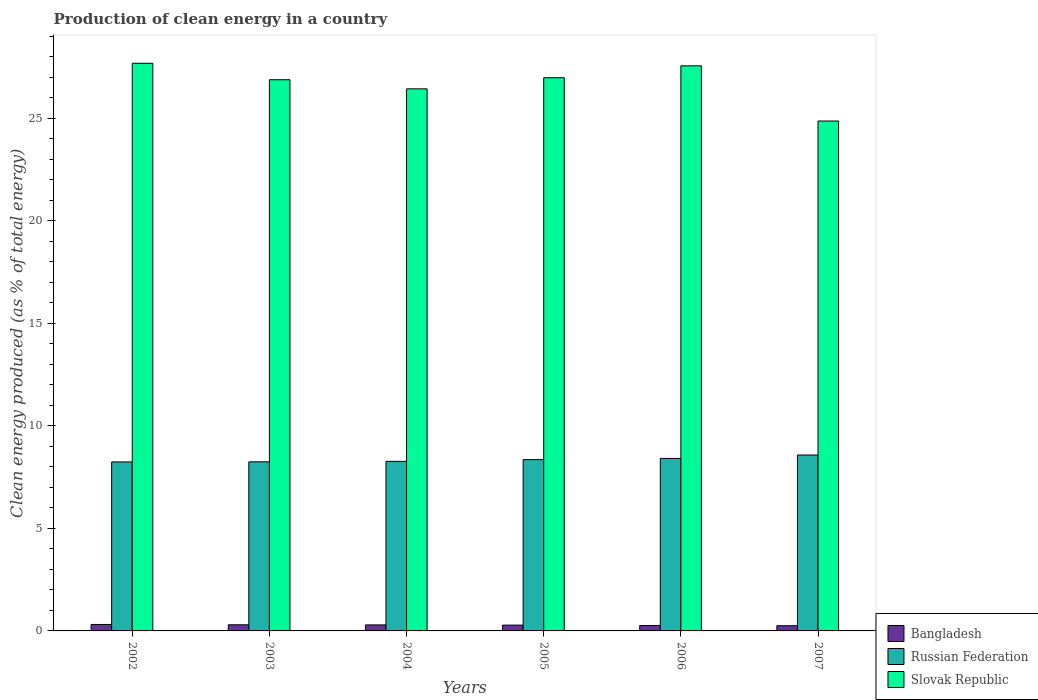Are the number of bars per tick equal to the number of legend labels?
Offer a terse response. Yes. How many bars are there on the 6th tick from the left?
Ensure brevity in your answer.  3. How many bars are there on the 1st tick from the right?
Provide a short and direct response. 3. What is the percentage of clean energy produced in Slovak Republic in 2007?
Offer a terse response. 24.87. Across all years, what is the maximum percentage of clean energy produced in Slovak Republic?
Ensure brevity in your answer.  27.69. Across all years, what is the minimum percentage of clean energy produced in Slovak Republic?
Your answer should be very brief. 24.87. In which year was the percentage of clean energy produced in Russian Federation minimum?
Your answer should be very brief. 2002. What is the total percentage of clean energy produced in Bangladesh in the graph?
Offer a very short reply. 1.71. What is the difference between the percentage of clean energy produced in Russian Federation in 2005 and that in 2007?
Give a very brief answer. -0.22. What is the difference between the percentage of clean energy produced in Russian Federation in 2007 and the percentage of clean energy produced in Slovak Republic in 2006?
Keep it short and to the point. -18.98. What is the average percentage of clean energy produced in Bangladesh per year?
Make the answer very short. 0.28. In the year 2002, what is the difference between the percentage of clean energy produced in Russian Federation and percentage of clean energy produced in Bangladesh?
Your response must be concise. 7.93. In how many years, is the percentage of clean energy produced in Russian Federation greater than 8 %?
Your response must be concise. 6. What is the ratio of the percentage of clean energy produced in Russian Federation in 2003 to that in 2004?
Keep it short and to the point. 1. Is the difference between the percentage of clean energy produced in Russian Federation in 2003 and 2006 greater than the difference between the percentage of clean energy produced in Bangladesh in 2003 and 2006?
Make the answer very short. No. What is the difference between the highest and the second highest percentage of clean energy produced in Russian Federation?
Your answer should be compact. 0.17. What is the difference between the highest and the lowest percentage of clean energy produced in Bangladesh?
Offer a terse response. 0.06. Is the sum of the percentage of clean energy produced in Bangladesh in 2004 and 2005 greater than the maximum percentage of clean energy produced in Russian Federation across all years?
Offer a very short reply. No. What does the 3rd bar from the left in 2006 represents?
Provide a succinct answer. Slovak Republic. What does the 2nd bar from the right in 2006 represents?
Offer a terse response. Russian Federation. Is it the case that in every year, the sum of the percentage of clean energy produced in Slovak Republic and percentage of clean energy produced in Bangladesh is greater than the percentage of clean energy produced in Russian Federation?
Ensure brevity in your answer.  Yes. Are all the bars in the graph horizontal?
Provide a short and direct response. No. What is the difference between two consecutive major ticks on the Y-axis?
Ensure brevity in your answer.  5. Are the values on the major ticks of Y-axis written in scientific E-notation?
Ensure brevity in your answer.  No. Does the graph contain any zero values?
Your answer should be compact. No. Does the graph contain grids?
Your answer should be compact. No. Where does the legend appear in the graph?
Give a very brief answer. Bottom right. What is the title of the graph?
Your answer should be very brief. Production of clean energy in a country. Does "Germany" appear as one of the legend labels in the graph?
Offer a very short reply. No. What is the label or title of the Y-axis?
Provide a short and direct response. Clean energy produced (as % of total energy). What is the Clean energy produced (as % of total energy) of Bangladesh in 2002?
Provide a succinct answer. 0.32. What is the Clean energy produced (as % of total energy) of Russian Federation in 2002?
Offer a very short reply. 8.24. What is the Clean energy produced (as % of total energy) in Slovak Republic in 2002?
Ensure brevity in your answer.  27.69. What is the Clean energy produced (as % of total energy) in Bangladesh in 2003?
Provide a short and direct response. 0.3. What is the Clean energy produced (as % of total energy) in Russian Federation in 2003?
Offer a terse response. 8.25. What is the Clean energy produced (as % of total energy) in Slovak Republic in 2003?
Make the answer very short. 26.88. What is the Clean energy produced (as % of total energy) in Bangladesh in 2004?
Keep it short and to the point. 0.29. What is the Clean energy produced (as % of total energy) in Russian Federation in 2004?
Offer a very short reply. 8.27. What is the Clean energy produced (as % of total energy) in Slovak Republic in 2004?
Give a very brief answer. 26.44. What is the Clean energy produced (as % of total energy) of Bangladesh in 2005?
Keep it short and to the point. 0.28. What is the Clean energy produced (as % of total energy) in Russian Federation in 2005?
Offer a terse response. 8.36. What is the Clean energy produced (as % of total energy) in Slovak Republic in 2005?
Offer a terse response. 26.98. What is the Clean energy produced (as % of total energy) of Bangladesh in 2006?
Keep it short and to the point. 0.27. What is the Clean energy produced (as % of total energy) of Russian Federation in 2006?
Make the answer very short. 8.41. What is the Clean energy produced (as % of total energy) in Slovak Republic in 2006?
Give a very brief answer. 27.56. What is the Clean energy produced (as % of total energy) of Bangladesh in 2007?
Provide a succinct answer. 0.25. What is the Clean energy produced (as % of total energy) in Russian Federation in 2007?
Your answer should be compact. 8.58. What is the Clean energy produced (as % of total energy) in Slovak Republic in 2007?
Ensure brevity in your answer.  24.87. Across all years, what is the maximum Clean energy produced (as % of total energy) of Bangladesh?
Make the answer very short. 0.32. Across all years, what is the maximum Clean energy produced (as % of total energy) in Russian Federation?
Your response must be concise. 8.58. Across all years, what is the maximum Clean energy produced (as % of total energy) in Slovak Republic?
Keep it short and to the point. 27.69. Across all years, what is the minimum Clean energy produced (as % of total energy) in Bangladesh?
Your response must be concise. 0.25. Across all years, what is the minimum Clean energy produced (as % of total energy) in Russian Federation?
Your answer should be very brief. 8.24. Across all years, what is the minimum Clean energy produced (as % of total energy) of Slovak Republic?
Make the answer very short. 24.87. What is the total Clean energy produced (as % of total energy) of Bangladesh in the graph?
Offer a terse response. 1.71. What is the total Clean energy produced (as % of total energy) in Russian Federation in the graph?
Offer a terse response. 50.11. What is the total Clean energy produced (as % of total energy) of Slovak Republic in the graph?
Provide a short and direct response. 160.43. What is the difference between the Clean energy produced (as % of total energy) in Bangladesh in 2002 and that in 2003?
Make the answer very short. 0.02. What is the difference between the Clean energy produced (as % of total energy) in Russian Federation in 2002 and that in 2003?
Give a very brief answer. -0. What is the difference between the Clean energy produced (as % of total energy) in Slovak Republic in 2002 and that in 2003?
Provide a short and direct response. 0.8. What is the difference between the Clean energy produced (as % of total energy) of Bangladesh in 2002 and that in 2004?
Your response must be concise. 0.02. What is the difference between the Clean energy produced (as % of total energy) in Russian Federation in 2002 and that in 2004?
Your response must be concise. -0.03. What is the difference between the Clean energy produced (as % of total energy) in Slovak Republic in 2002 and that in 2004?
Give a very brief answer. 1.25. What is the difference between the Clean energy produced (as % of total energy) in Bangladesh in 2002 and that in 2005?
Offer a very short reply. 0.03. What is the difference between the Clean energy produced (as % of total energy) in Russian Federation in 2002 and that in 2005?
Your response must be concise. -0.11. What is the difference between the Clean energy produced (as % of total energy) of Slovak Republic in 2002 and that in 2005?
Give a very brief answer. 0.7. What is the difference between the Clean energy produced (as % of total energy) in Bangladesh in 2002 and that in 2006?
Give a very brief answer. 0.05. What is the difference between the Clean energy produced (as % of total energy) of Russian Federation in 2002 and that in 2006?
Offer a very short reply. -0.17. What is the difference between the Clean energy produced (as % of total energy) of Slovak Republic in 2002 and that in 2006?
Keep it short and to the point. 0.13. What is the difference between the Clean energy produced (as % of total energy) in Bangladesh in 2002 and that in 2007?
Give a very brief answer. 0.06. What is the difference between the Clean energy produced (as % of total energy) of Russian Federation in 2002 and that in 2007?
Offer a terse response. -0.34. What is the difference between the Clean energy produced (as % of total energy) in Slovak Republic in 2002 and that in 2007?
Your answer should be compact. 2.82. What is the difference between the Clean energy produced (as % of total energy) in Bangladesh in 2003 and that in 2004?
Offer a terse response. 0.01. What is the difference between the Clean energy produced (as % of total energy) of Russian Federation in 2003 and that in 2004?
Offer a terse response. -0.02. What is the difference between the Clean energy produced (as % of total energy) in Slovak Republic in 2003 and that in 2004?
Ensure brevity in your answer.  0.44. What is the difference between the Clean energy produced (as % of total energy) of Bangladesh in 2003 and that in 2005?
Ensure brevity in your answer.  0.02. What is the difference between the Clean energy produced (as % of total energy) of Russian Federation in 2003 and that in 2005?
Your answer should be compact. -0.11. What is the difference between the Clean energy produced (as % of total energy) in Slovak Republic in 2003 and that in 2005?
Your answer should be very brief. -0.1. What is the difference between the Clean energy produced (as % of total energy) of Bangladesh in 2003 and that in 2006?
Offer a terse response. 0.03. What is the difference between the Clean energy produced (as % of total energy) in Russian Federation in 2003 and that in 2006?
Your answer should be very brief. -0.17. What is the difference between the Clean energy produced (as % of total energy) in Slovak Republic in 2003 and that in 2006?
Offer a terse response. -0.68. What is the difference between the Clean energy produced (as % of total energy) in Bangladesh in 2003 and that in 2007?
Make the answer very short. 0.05. What is the difference between the Clean energy produced (as % of total energy) in Russian Federation in 2003 and that in 2007?
Offer a very short reply. -0.33. What is the difference between the Clean energy produced (as % of total energy) in Slovak Republic in 2003 and that in 2007?
Your answer should be very brief. 2.01. What is the difference between the Clean energy produced (as % of total energy) in Bangladesh in 2004 and that in 2005?
Keep it short and to the point. 0.01. What is the difference between the Clean energy produced (as % of total energy) in Russian Federation in 2004 and that in 2005?
Provide a succinct answer. -0.09. What is the difference between the Clean energy produced (as % of total energy) in Slovak Republic in 2004 and that in 2005?
Your answer should be compact. -0.54. What is the difference between the Clean energy produced (as % of total energy) in Bangladesh in 2004 and that in 2006?
Your answer should be compact. 0.03. What is the difference between the Clean energy produced (as % of total energy) in Russian Federation in 2004 and that in 2006?
Your response must be concise. -0.14. What is the difference between the Clean energy produced (as % of total energy) of Slovak Republic in 2004 and that in 2006?
Your response must be concise. -1.12. What is the difference between the Clean energy produced (as % of total energy) in Bangladesh in 2004 and that in 2007?
Make the answer very short. 0.04. What is the difference between the Clean energy produced (as % of total energy) in Russian Federation in 2004 and that in 2007?
Keep it short and to the point. -0.31. What is the difference between the Clean energy produced (as % of total energy) in Slovak Republic in 2004 and that in 2007?
Ensure brevity in your answer.  1.57. What is the difference between the Clean energy produced (as % of total energy) of Bangladesh in 2005 and that in 2006?
Provide a succinct answer. 0.02. What is the difference between the Clean energy produced (as % of total energy) of Russian Federation in 2005 and that in 2006?
Make the answer very short. -0.06. What is the difference between the Clean energy produced (as % of total energy) of Slovak Republic in 2005 and that in 2006?
Offer a terse response. -0.58. What is the difference between the Clean energy produced (as % of total energy) in Bangladesh in 2005 and that in 2007?
Your response must be concise. 0.03. What is the difference between the Clean energy produced (as % of total energy) in Russian Federation in 2005 and that in 2007?
Offer a very short reply. -0.22. What is the difference between the Clean energy produced (as % of total energy) in Slovak Republic in 2005 and that in 2007?
Your answer should be compact. 2.11. What is the difference between the Clean energy produced (as % of total energy) in Bangladesh in 2006 and that in 2007?
Offer a terse response. 0.01. What is the difference between the Clean energy produced (as % of total energy) of Russian Federation in 2006 and that in 2007?
Make the answer very short. -0.17. What is the difference between the Clean energy produced (as % of total energy) in Slovak Republic in 2006 and that in 2007?
Provide a succinct answer. 2.69. What is the difference between the Clean energy produced (as % of total energy) in Bangladesh in 2002 and the Clean energy produced (as % of total energy) in Russian Federation in 2003?
Offer a very short reply. -7.93. What is the difference between the Clean energy produced (as % of total energy) of Bangladesh in 2002 and the Clean energy produced (as % of total energy) of Slovak Republic in 2003?
Provide a short and direct response. -26.57. What is the difference between the Clean energy produced (as % of total energy) of Russian Federation in 2002 and the Clean energy produced (as % of total energy) of Slovak Republic in 2003?
Provide a succinct answer. -18.64. What is the difference between the Clean energy produced (as % of total energy) in Bangladesh in 2002 and the Clean energy produced (as % of total energy) in Russian Federation in 2004?
Make the answer very short. -7.96. What is the difference between the Clean energy produced (as % of total energy) in Bangladesh in 2002 and the Clean energy produced (as % of total energy) in Slovak Republic in 2004?
Offer a very short reply. -26.12. What is the difference between the Clean energy produced (as % of total energy) in Russian Federation in 2002 and the Clean energy produced (as % of total energy) in Slovak Republic in 2004?
Give a very brief answer. -18.2. What is the difference between the Clean energy produced (as % of total energy) of Bangladesh in 2002 and the Clean energy produced (as % of total energy) of Russian Federation in 2005?
Your answer should be compact. -8.04. What is the difference between the Clean energy produced (as % of total energy) in Bangladesh in 2002 and the Clean energy produced (as % of total energy) in Slovak Republic in 2005?
Your response must be concise. -26.67. What is the difference between the Clean energy produced (as % of total energy) of Russian Federation in 2002 and the Clean energy produced (as % of total energy) of Slovak Republic in 2005?
Give a very brief answer. -18.74. What is the difference between the Clean energy produced (as % of total energy) of Bangladesh in 2002 and the Clean energy produced (as % of total energy) of Russian Federation in 2006?
Your answer should be compact. -8.1. What is the difference between the Clean energy produced (as % of total energy) of Bangladesh in 2002 and the Clean energy produced (as % of total energy) of Slovak Republic in 2006?
Offer a very short reply. -27.25. What is the difference between the Clean energy produced (as % of total energy) of Russian Federation in 2002 and the Clean energy produced (as % of total energy) of Slovak Republic in 2006?
Make the answer very short. -19.32. What is the difference between the Clean energy produced (as % of total energy) in Bangladesh in 2002 and the Clean energy produced (as % of total energy) in Russian Federation in 2007?
Give a very brief answer. -8.26. What is the difference between the Clean energy produced (as % of total energy) of Bangladesh in 2002 and the Clean energy produced (as % of total energy) of Slovak Republic in 2007?
Keep it short and to the point. -24.55. What is the difference between the Clean energy produced (as % of total energy) in Russian Federation in 2002 and the Clean energy produced (as % of total energy) in Slovak Republic in 2007?
Offer a terse response. -16.63. What is the difference between the Clean energy produced (as % of total energy) of Bangladesh in 2003 and the Clean energy produced (as % of total energy) of Russian Federation in 2004?
Keep it short and to the point. -7.97. What is the difference between the Clean energy produced (as % of total energy) in Bangladesh in 2003 and the Clean energy produced (as % of total energy) in Slovak Republic in 2004?
Ensure brevity in your answer.  -26.14. What is the difference between the Clean energy produced (as % of total energy) of Russian Federation in 2003 and the Clean energy produced (as % of total energy) of Slovak Republic in 2004?
Ensure brevity in your answer.  -18.19. What is the difference between the Clean energy produced (as % of total energy) in Bangladesh in 2003 and the Clean energy produced (as % of total energy) in Russian Federation in 2005?
Your response must be concise. -8.06. What is the difference between the Clean energy produced (as % of total energy) in Bangladesh in 2003 and the Clean energy produced (as % of total energy) in Slovak Republic in 2005?
Keep it short and to the point. -26.68. What is the difference between the Clean energy produced (as % of total energy) of Russian Federation in 2003 and the Clean energy produced (as % of total energy) of Slovak Republic in 2005?
Your response must be concise. -18.74. What is the difference between the Clean energy produced (as % of total energy) of Bangladesh in 2003 and the Clean energy produced (as % of total energy) of Russian Federation in 2006?
Your answer should be compact. -8.11. What is the difference between the Clean energy produced (as % of total energy) of Bangladesh in 2003 and the Clean energy produced (as % of total energy) of Slovak Republic in 2006?
Your answer should be very brief. -27.26. What is the difference between the Clean energy produced (as % of total energy) in Russian Federation in 2003 and the Clean energy produced (as % of total energy) in Slovak Republic in 2006?
Offer a very short reply. -19.31. What is the difference between the Clean energy produced (as % of total energy) in Bangladesh in 2003 and the Clean energy produced (as % of total energy) in Russian Federation in 2007?
Keep it short and to the point. -8.28. What is the difference between the Clean energy produced (as % of total energy) in Bangladesh in 2003 and the Clean energy produced (as % of total energy) in Slovak Republic in 2007?
Your answer should be very brief. -24.57. What is the difference between the Clean energy produced (as % of total energy) of Russian Federation in 2003 and the Clean energy produced (as % of total energy) of Slovak Republic in 2007?
Give a very brief answer. -16.62. What is the difference between the Clean energy produced (as % of total energy) of Bangladesh in 2004 and the Clean energy produced (as % of total energy) of Russian Federation in 2005?
Keep it short and to the point. -8.06. What is the difference between the Clean energy produced (as % of total energy) of Bangladesh in 2004 and the Clean energy produced (as % of total energy) of Slovak Republic in 2005?
Your answer should be very brief. -26.69. What is the difference between the Clean energy produced (as % of total energy) in Russian Federation in 2004 and the Clean energy produced (as % of total energy) in Slovak Republic in 2005?
Offer a terse response. -18.71. What is the difference between the Clean energy produced (as % of total energy) of Bangladesh in 2004 and the Clean energy produced (as % of total energy) of Russian Federation in 2006?
Offer a terse response. -8.12. What is the difference between the Clean energy produced (as % of total energy) of Bangladesh in 2004 and the Clean energy produced (as % of total energy) of Slovak Republic in 2006?
Provide a short and direct response. -27.27. What is the difference between the Clean energy produced (as % of total energy) in Russian Federation in 2004 and the Clean energy produced (as % of total energy) in Slovak Republic in 2006?
Provide a short and direct response. -19.29. What is the difference between the Clean energy produced (as % of total energy) of Bangladesh in 2004 and the Clean energy produced (as % of total energy) of Russian Federation in 2007?
Offer a terse response. -8.29. What is the difference between the Clean energy produced (as % of total energy) of Bangladesh in 2004 and the Clean energy produced (as % of total energy) of Slovak Republic in 2007?
Offer a terse response. -24.58. What is the difference between the Clean energy produced (as % of total energy) of Russian Federation in 2004 and the Clean energy produced (as % of total energy) of Slovak Republic in 2007?
Your response must be concise. -16.6. What is the difference between the Clean energy produced (as % of total energy) in Bangladesh in 2005 and the Clean energy produced (as % of total energy) in Russian Federation in 2006?
Make the answer very short. -8.13. What is the difference between the Clean energy produced (as % of total energy) in Bangladesh in 2005 and the Clean energy produced (as % of total energy) in Slovak Republic in 2006?
Ensure brevity in your answer.  -27.28. What is the difference between the Clean energy produced (as % of total energy) in Russian Federation in 2005 and the Clean energy produced (as % of total energy) in Slovak Republic in 2006?
Make the answer very short. -19.21. What is the difference between the Clean energy produced (as % of total energy) in Bangladesh in 2005 and the Clean energy produced (as % of total energy) in Russian Federation in 2007?
Ensure brevity in your answer.  -8.3. What is the difference between the Clean energy produced (as % of total energy) in Bangladesh in 2005 and the Clean energy produced (as % of total energy) in Slovak Republic in 2007?
Provide a succinct answer. -24.59. What is the difference between the Clean energy produced (as % of total energy) of Russian Federation in 2005 and the Clean energy produced (as % of total energy) of Slovak Republic in 2007?
Provide a succinct answer. -16.51. What is the difference between the Clean energy produced (as % of total energy) of Bangladesh in 2006 and the Clean energy produced (as % of total energy) of Russian Federation in 2007?
Make the answer very short. -8.31. What is the difference between the Clean energy produced (as % of total energy) of Bangladesh in 2006 and the Clean energy produced (as % of total energy) of Slovak Republic in 2007?
Your response must be concise. -24.6. What is the difference between the Clean energy produced (as % of total energy) in Russian Federation in 2006 and the Clean energy produced (as % of total energy) in Slovak Republic in 2007?
Your answer should be compact. -16.46. What is the average Clean energy produced (as % of total energy) of Bangladesh per year?
Make the answer very short. 0.28. What is the average Clean energy produced (as % of total energy) in Russian Federation per year?
Ensure brevity in your answer.  8.35. What is the average Clean energy produced (as % of total energy) of Slovak Republic per year?
Your answer should be compact. 26.74. In the year 2002, what is the difference between the Clean energy produced (as % of total energy) in Bangladesh and Clean energy produced (as % of total energy) in Russian Federation?
Make the answer very short. -7.93. In the year 2002, what is the difference between the Clean energy produced (as % of total energy) in Bangladesh and Clean energy produced (as % of total energy) in Slovak Republic?
Your response must be concise. -27.37. In the year 2002, what is the difference between the Clean energy produced (as % of total energy) of Russian Federation and Clean energy produced (as % of total energy) of Slovak Republic?
Ensure brevity in your answer.  -19.44. In the year 2003, what is the difference between the Clean energy produced (as % of total energy) of Bangladesh and Clean energy produced (as % of total energy) of Russian Federation?
Provide a succinct answer. -7.95. In the year 2003, what is the difference between the Clean energy produced (as % of total energy) of Bangladesh and Clean energy produced (as % of total energy) of Slovak Republic?
Offer a very short reply. -26.58. In the year 2003, what is the difference between the Clean energy produced (as % of total energy) of Russian Federation and Clean energy produced (as % of total energy) of Slovak Republic?
Give a very brief answer. -18.64. In the year 2004, what is the difference between the Clean energy produced (as % of total energy) of Bangladesh and Clean energy produced (as % of total energy) of Russian Federation?
Provide a short and direct response. -7.98. In the year 2004, what is the difference between the Clean energy produced (as % of total energy) in Bangladesh and Clean energy produced (as % of total energy) in Slovak Republic?
Your answer should be compact. -26.15. In the year 2004, what is the difference between the Clean energy produced (as % of total energy) of Russian Federation and Clean energy produced (as % of total energy) of Slovak Republic?
Keep it short and to the point. -18.17. In the year 2005, what is the difference between the Clean energy produced (as % of total energy) in Bangladesh and Clean energy produced (as % of total energy) in Russian Federation?
Give a very brief answer. -8.07. In the year 2005, what is the difference between the Clean energy produced (as % of total energy) in Bangladesh and Clean energy produced (as % of total energy) in Slovak Republic?
Keep it short and to the point. -26.7. In the year 2005, what is the difference between the Clean energy produced (as % of total energy) of Russian Federation and Clean energy produced (as % of total energy) of Slovak Republic?
Provide a short and direct response. -18.63. In the year 2006, what is the difference between the Clean energy produced (as % of total energy) in Bangladesh and Clean energy produced (as % of total energy) in Russian Federation?
Your answer should be very brief. -8.15. In the year 2006, what is the difference between the Clean energy produced (as % of total energy) in Bangladesh and Clean energy produced (as % of total energy) in Slovak Republic?
Provide a succinct answer. -27.3. In the year 2006, what is the difference between the Clean energy produced (as % of total energy) in Russian Federation and Clean energy produced (as % of total energy) in Slovak Republic?
Provide a short and direct response. -19.15. In the year 2007, what is the difference between the Clean energy produced (as % of total energy) in Bangladesh and Clean energy produced (as % of total energy) in Russian Federation?
Provide a short and direct response. -8.33. In the year 2007, what is the difference between the Clean energy produced (as % of total energy) in Bangladesh and Clean energy produced (as % of total energy) in Slovak Republic?
Your answer should be very brief. -24.62. In the year 2007, what is the difference between the Clean energy produced (as % of total energy) of Russian Federation and Clean energy produced (as % of total energy) of Slovak Republic?
Provide a succinct answer. -16.29. What is the ratio of the Clean energy produced (as % of total energy) of Bangladesh in 2002 to that in 2003?
Offer a terse response. 1.05. What is the ratio of the Clean energy produced (as % of total energy) of Russian Federation in 2002 to that in 2003?
Ensure brevity in your answer.  1. What is the ratio of the Clean energy produced (as % of total energy) in Slovak Republic in 2002 to that in 2003?
Your answer should be compact. 1.03. What is the ratio of the Clean energy produced (as % of total energy) of Bangladesh in 2002 to that in 2004?
Your answer should be very brief. 1.07. What is the ratio of the Clean energy produced (as % of total energy) in Russian Federation in 2002 to that in 2004?
Make the answer very short. 1. What is the ratio of the Clean energy produced (as % of total energy) of Slovak Republic in 2002 to that in 2004?
Keep it short and to the point. 1.05. What is the ratio of the Clean energy produced (as % of total energy) of Bangladesh in 2002 to that in 2005?
Your answer should be compact. 1.11. What is the ratio of the Clean energy produced (as % of total energy) of Russian Federation in 2002 to that in 2005?
Offer a very short reply. 0.99. What is the ratio of the Clean energy produced (as % of total energy) of Slovak Republic in 2002 to that in 2005?
Give a very brief answer. 1.03. What is the ratio of the Clean energy produced (as % of total energy) in Bangladesh in 2002 to that in 2006?
Give a very brief answer. 1.19. What is the ratio of the Clean energy produced (as % of total energy) of Russian Federation in 2002 to that in 2006?
Provide a short and direct response. 0.98. What is the ratio of the Clean energy produced (as % of total energy) of Slovak Republic in 2002 to that in 2006?
Your answer should be compact. 1. What is the ratio of the Clean energy produced (as % of total energy) in Bangladesh in 2002 to that in 2007?
Offer a terse response. 1.25. What is the ratio of the Clean energy produced (as % of total energy) of Russian Federation in 2002 to that in 2007?
Offer a very short reply. 0.96. What is the ratio of the Clean energy produced (as % of total energy) in Slovak Republic in 2002 to that in 2007?
Ensure brevity in your answer.  1.11. What is the ratio of the Clean energy produced (as % of total energy) in Bangladesh in 2003 to that in 2004?
Ensure brevity in your answer.  1.02. What is the ratio of the Clean energy produced (as % of total energy) of Russian Federation in 2003 to that in 2004?
Your answer should be compact. 1. What is the ratio of the Clean energy produced (as % of total energy) of Slovak Republic in 2003 to that in 2004?
Offer a terse response. 1.02. What is the ratio of the Clean energy produced (as % of total energy) of Bangladesh in 2003 to that in 2005?
Provide a short and direct response. 1.06. What is the ratio of the Clean energy produced (as % of total energy) in Slovak Republic in 2003 to that in 2005?
Make the answer very short. 1. What is the ratio of the Clean energy produced (as % of total energy) in Bangladesh in 2003 to that in 2006?
Provide a short and direct response. 1.13. What is the ratio of the Clean energy produced (as % of total energy) in Russian Federation in 2003 to that in 2006?
Your answer should be compact. 0.98. What is the ratio of the Clean energy produced (as % of total energy) in Slovak Republic in 2003 to that in 2006?
Offer a very short reply. 0.98. What is the ratio of the Clean energy produced (as % of total energy) in Bangladesh in 2003 to that in 2007?
Offer a terse response. 1.18. What is the ratio of the Clean energy produced (as % of total energy) of Russian Federation in 2003 to that in 2007?
Your answer should be very brief. 0.96. What is the ratio of the Clean energy produced (as % of total energy) of Slovak Republic in 2003 to that in 2007?
Give a very brief answer. 1.08. What is the ratio of the Clean energy produced (as % of total energy) in Bangladesh in 2004 to that in 2005?
Offer a terse response. 1.04. What is the ratio of the Clean energy produced (as % of total energy) of Russian Federation in 2004 to that in 2005?
Ensure brevity in your answer.  0.99. What is the ratio of the Clean energy produced (as % of total energy) in Slovak Republic in 2004 to that in 2005?
Your answer should be compact. 0.98. What is the ratio of the Clean energy produced (as % of total energy) of Bangladesh in 2004 to that in 2006?
Offer a terse response. 1.11. What is the ratio of the Clean energy produced (as % of total energy) in Russian Federation in 2004 to that in 2006?
Provide a short and direct response. 0.98. What is the ratio of the Clean energy produced (as % of total energy) of Slovak Republic in 2004 to that in 2006?
Offer a terse response. 0.96. What is the ratio of the Clean energy produced (as % of total energy) in Bangladesh in 2004 to that in 2007?
Your response must be concise. 1.16. What is the ratio of the Clean energy produced (as % of total energy) in Slovak Republic in 2004 to that in 2007?
Offer a terse response. 1.06. What is the ratio of the Clean energy produced (as % of total energy) of Bangladesh in 2005 to that in 2006?
Offer a terse response. 1.07. What is the ratio of the Clean energy produced (as % of total energy) of Russian Federation in 2005 to that in 2006?
Offer a very short reply. 0.99. What is the ratio of the Clean energy produced (as % of total energy) in Slovak Republic in 2005 to that in 2006?
Provide a short and direct response. 0.98. What is the ratio of the Clean energy produced (as % of total energy) of Bangladesh in 2005 to that in 2007?
Provide a succinct answer. 1.12. What is the ratio of the Clean energy produced (as % of total energy) of Slovak Republic in 2005 to that in 2007?
Your response must be concise. 1.08. What is the ratio of the Clean energy produced (as % of total energy) of Bangladesh in 2006 to that in 2007?
Give a very brief answer. 1.05. What is the ratio of the Clean energy produced (as % of total energy) in Russian Federation in 2006 to that in 2007?
Offer a very short reply. 0.98. What is the ratio of the Clean energy produced (as % of total energy) of Slovak Republic in 2006 to that in 2007?
Provide a succinct answer. 1.11. What is the difference between the highest and the second highest Clean energy produced (as % of total energy) of Bangladesh?
Keep it short and to the point. 0.02. What is the difference between the highest and the second highest Clean energy produced (as % of total energy) in Russian Federation?
Offer a terse response. 0.17. What is the difference between the highest and the second highest Clean energy produced (as % of total energy) of Slovak Republic?
Offer a very short reply. 0.13. What is the difference between the highest and the lowest Clean energy produced (as % of total energy) of Bangladesh?
Provide a succinct answer. 0.06. What is the difference between the highest and the lowest Clean energy produced (as % of total energy) in Russian Federation?
Your response must be concise. 0.34. What is the difference between the highest and the lowest Clean energy produced (as % of total energy) of Slovak Republic?
Give a very brief answer. 2.82. 